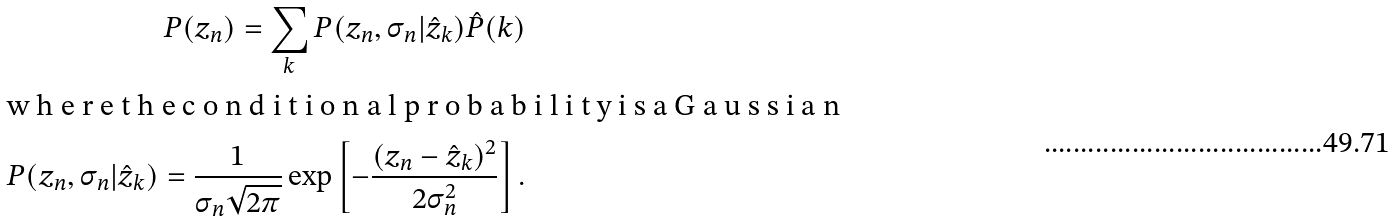<formula> <loc_0><loc_0><loc_500><loc_500>P ( z _ { n } ) = \sum _ { k } P ( z _ { n } , \sigma _ { n } | \hat { z } _ { k } ) \hat { P } ( k ) \intertext { w h e r e t h e c o n d i t i o n a l p r o b a b i l i t y i s a G a u s s i a n } P ( z _ { n } , \sigma _ { n } | \hat { z } _ { k } ) = \frac { 1 } { \sigma _ { n } \sqrt { 2 \pi } } \exp \left [ - \frac { ( z _ { n } - \hat { z } _ { k } ) ^ { 2 } } { 2 \sigma _ { n } ^ { 2 } } \right ] .</formula> 